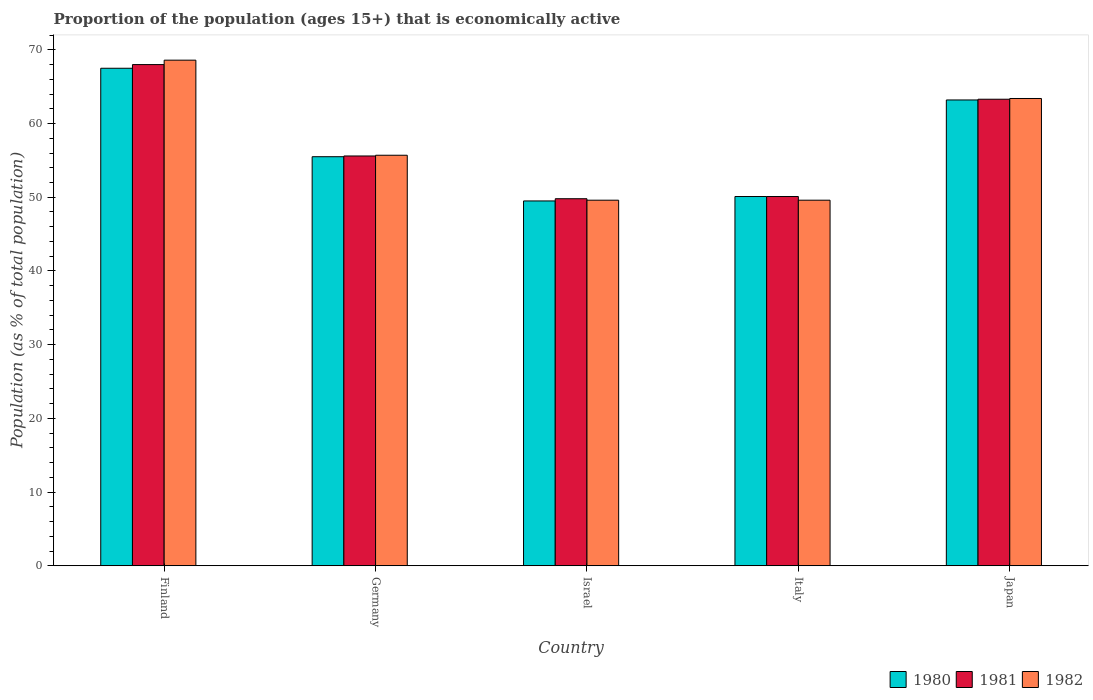How many groups of bars are there?
Give a very brief answer. 5. Are the number of bars on each tick of the X-axis equal?
Your answer should be very brief. Yes. In how many cases, is the number of bars for a given country not equal to the number of legend labels?
Your response must be concise. 0. What is the proportion of the population that is economically active in 1980 in Japan?
Offer a terse response. 63.2. Across all countries, what is the maximum proportion of the population that is economically active in 1980?
Give a very brief answer. 67.5. Across all countries, what is the minimum proportion of the population that is economically active in 1980?
Offer a terse response. 49.5. In which country was the proportion of the population that is economically active in 1980 maximum?
Ensure brevity in your answer.  Finland. What is the total proportion of the population that is economically active in 1980 in the graph?
Ensure brevity in your answer.  285.8. What is the difference between the proportion of the population that is economically active in 1980 in Israel and that in Italy?
Your answer should be very brief. -0.6. What is the difference between the proportion of the population that is economically active in 1982 in Italy and the proportion of the population that is economically active in 1981 in Finland?
Provide a succinct answer. -18.4. What is the average proportion of the population that is economically active in 1981 per country?
Offer a terse response. 57.36. What is the difference between the proportion of the population that is economically active of/in 1981 and proportion of the population that is economically active of/in 1980 in Japan?
Ensure brevity in your answer.  0.1. What is the ratio of the proportion of the population that is economically active in 1982 in Finland to that in Israel?
Offer a very short reply. 1.38. Is the proportion of the population that is economically active in 1981 in Italy less than that in Japan?
Give a very brief answer. Yes. Is the difference between the proportion of the population that is economically active in 1981 in Israel and Japan greater than the difference between the proportion of the population that is economically active in 1980 in Israel and Japan?
Give a very brief answer. Yes. What is the difference between the highest and the second highest proportion of the population that is economically active in 1981?
Your answer should be very brief. 12.4. What is the difference between the highest and the lowest proportion of the population that is economically active in 1982?
Offer a terse response. 19. In how many countries, is the proportion of the population that is economically active in 1980 greater than the average proportion of the population that is economically active in 1980 taken over all countries?
Your answer should be very brief. 2. Is it the case that in every country, the sum of the proportion of the population that is economically active in 1980 and proportion of the population that is economically active in 1982 is greater than the proportion of the population that is economically active in 1981?
Your answer should be very brief. Yes. How many bars are there?
Your answer should be compact. 15. What is the difference between two consecutive major ticks on the Y-axis?
Provide a succinct answer. 10. Are the values on the major ticks of Y-axis written in scientific E-notation?
Keep it short and to the point. No. Does the graph contain grids?
Keep it short and to the point. No. Where does the legend appear in the graph?
Offer a terse response. Bottom right. How many legend labels are there?
Keep it short and to the point. 3. How are the legend labels stacked?
Your answer should be compact. Horizontal. What is the title of the graph?
Give a very brief answer. Proportion of the population (ages 15+) that is economically active. Does "1980" appear as one of the legend labels in the graph?
Keep it short and to the point. Yes. What is the label or title of the X-axis?
Provide a short and direct response. Country. What is the label or title of the Y-axis?
Your response must be concise. Population (as % of total population). What is the Population (as % of total population) of 1980 in Finland?
Offer a terse response. 67.5. What is the Population (as % of total population) of 1982 in Finland?
Your answer should be compact. 68.6. What is the Population (as % of total population) in 1980 in Germany?
Ensure brevity in your answer.  55.5. What is the Population (as % of total population) in 1981 in Germany?
Provide a succinct answer. 55.6. What is the Population (as % of total population) of 1982 in Germany?
Give a very brief answer. 55.7. What is the Population (as % of total population) in 1980 in Israel?
Your response must be concise. 49.5. What is the Population (as % of total population) of 1981 in Israel?
Offer a very short reply. 49.8. What is the Population (as % of total population) of 1982 in Israel?
Give a very brief answer. 49.6. What is the Population (as % of total population) in 1980 in Italy?
Provide a succinct answer. 50.1. What is the Population (as % of total population) in 1981 in Italy?
Your answer should be very brief. 50.1. What is the Population (as % of total population) in 1982 in Italy?
Offer a terse response. 49.6. What is the Population (as % of total population) of 1980 in Japan?
Your answer should be very brief. 63.2. What is the Population (as % of total population) in 1981 in Japan?
Give a very brief answer. 63.3. What is the Population (as % of total population) of 1982 in Japan?
Ensure brevity in your answer.  63.4. Across all countries, what is the maximum Population (as % of total population) in 1980?
Offer a very short reply. 67.5. Across all countries, what is the maximum Population (as % of total population) in 1981?
Provide a short and direct response. 68. Across all countries, what is the maximum Population (as % of total population) in 1982?
Provide a short and direct response. 68.6. Across all countries, what is the minimum Population (as % of total population) in 1980?
Provide a succinct answer. 49.5. Across all countries, what is the minimum Population (as % of total population) in 1981?
Offer a very short reply. 49.8. Across all countries, what is the minimum Population (as % of total population) of 1982?
Ensure brevity in your answer.  49.6. What is the total Population (as % of total population) in 1980 in the graph?
Keep it short and to the point. 285.8. What is the total Population (as % of total population) in 1981 in the graph?
Your answer should be very brief. 286.8. What is the total Population (as % of total population) of 1982 in the graph?
Provide a short and direct response. 286.9. What is the difference between the Population (as % of total population) of 1980 in Finland and that in Germany?
Offer a terse response. 12. What is the difference between the Population (as % of total population) in 1981 in Finland and that in Germany?
Offer a terse response. 12.4. What is the difference between the Population (as % of total population) in 1980 in Finland and that in Israel?
Your answer should be compact. 18. What is the difference between the Population (as % of total population) of 1981 in Finland and that in Israel?
Keep it short and to the point. 18.2. What is the difference between the Population (as % of total population) in 1981 in Finland and that in Italy?
Offer a very short reply. 17.9. What is the difference between the Population (as % of total population) in 1982 in Finland and that in Italy?
Your answer should be compact. 19. What is the difference between the Population (as % of total population) in 1982 in Finland and that in Japan?
Offer a very short reply. 5.2. What is the difference between the Population (as % of total population) of 1980 in Germany and that in Israel?
Keep it short and to the point. 6. What is the difference between the Population (as % of total population) of 1980 in Germany and that in Italy?
Your response must be concise. 5.4. What is the difference between the Population (as % of total population) in 1982 in Germany and that in Italy?
Give a very brief answer. 6.1. What is the difference between the Population (as % of total population) in 1982 in Germany and that in Japan?
Offer a terse response. -7.7. What is the difference between the Population (as % of total population) in 1982 in Israel and that in Italy?
Provide a succinct answer. 0. What is the difference between the Population (as % of total population) of 1980 in Israel and that in Japan?
Ensure brevity in your answer.  -13.7. What is the difference between the Population (as % of total population) of 1980 in Italy and that in Japan?
Offer a very short reply. -13.1. What is the difference between the Population (as % of total population) in 1980 in Finland and the Population (as % of total population) in 1981 in Germany?
Provide a succinct answer. 11.9. What is the difference between the Population (as % of total population) in 1981 in Finland and the Population (as % of total population) in 1982 in Germany?
Offer a terse response. 12.3. What is the difference between the Population (as % of total population) of 1980 in Finland and the Population (as % of total population) of 1982 in Israel?
Keep it short and to the point. 17.9. What is the difference between the Population (as % of total population) of 1980 in Finland and the Population (as % of total population) of 1982 in Italy?
Provide a short and direct response. 17.9. What is the difference between the Population (as % of total population) of 1981 in Finland and the Population (as % of total population) of 1982 in Italy?
Your answer should be compact. 18.4. What is the difference between the Population (as % of total population) in 1981 in Finland and the Population (as % of total population) in 1982 in Japan?
Keep it short and to the point. 4.6. What is the difference between the Population (as % of total population) of 1980 in Germany and the Population (as % of total population) of 1981 in Israel?
Your answer should be compact. 5.7. What is the difference between the Population (as % of total population) in 1980 in Germany and the Population (as % of total population) in 1982 in Israel?
Provide a short and direct response. 5.9. What is the difference between the Population (as % of total population) in 1981 in Germany and the Population (as % of total population) in 1982 in Israel?
Your response must be concise. 6. What is the difference between the Population (as % of total population) of 1980 in Germany and the Population (as % of total population) of 1981 in Italy?
Your answer should be very brief. 5.4. What is the difference between the Population (as % of total population) in 1981 in Germany and the Population (as % of total population) in 1982 in Italy?
Make the answer very short. 6. What is the difference between the Population (as % of total population) in 1981 in Germany and the Population (as % of total population) in 1982 in Japan?
Provide a succinct answer. -7.8. What is the difference between the Population (as % of total population) of 1980 in Israel and the Population (as % of total population) of 1981 in Italy?
Your answer should be very brief. -0.6. What is the difference between the Population (as % of total population) in 1980 in Israel and the Population (as % of total population) in 1982 in Italy?
Make the answer very short. -0.1. What is the difference between the Population (as % of total population) of 1981 in Israel and the Population (as % of total population) of 1982 in Italy?
Provide a succinct answer. 0.2. What is the difference between the Population (as % of total population) of 1980 in Italy and the Population (as % of total population) of 1981 in Japan?
Make the answer very short. -13.2. What is the difference between the Population (as % of total population) in 1980 in Italy and the Population (as % of total population) in 1982 in Japan?
Provide a short and direct response. -13.3. What is the average Population (as % of total population) in 1980 per country?
Provide a succinct answer. 57.16. What is the average Population (as % of total population) in 1981 per country?
Offer a terse response. 57.36. What is the average Population (as % of total population) in 1982 per country?
Offer a very short reply. 57.38. What is the difference between the Population (as % of total population) in 1980 and Population (as % of total population) in 1981 in Finland?
Your response must be concise. -0.5. What is the difference between the Population (as % of total population) of 1981 and Population (as % of total population) of 1982 in Finland?
Your answer should be very brief. -0.6. What is the difference between the Population (as % of total population) of 1981 and Population (as % of total population) of 1982 in Germany?
Ensure brevity in your answer.  -0.1. What is the difference between the Population (as % of total population) of 1980 and Population (as % of total population) of 1981 in Israel?
Offer a terse response. -0.3. What is the difference between the Population (as % of total population) of 1980 and Population (as % of total population) of 1982 in Israel?
Your answer should be compact. -0.1. What is the difference between the Population (as % of total population) of 1981 and Population (as % of total population) of 1982 in Israel?
Ensure brevity in your answer.  0.2. What is the difference between the Population (as % of total population) of 1980 and Population (as % of total population) of 1982 in Italy?
Your response must be concise. 0.5. What is the difference between the Population (as % of total population) of 1981 and Population (as % of total population) of 1982 in Italy?
Keep it short and to the point. 0.5. What is the ratio of the Population (as % of total population) in 1980 in Finland to that in Germany?
Keep it short and to the point. 1.22. What is the ratio of the Population (as % of total population) in 1981 in Finland to that in Germany?
Make the answer very short. 1.22. What is the ratio of the Population (as % of total population) in 1982 in Finland to that in Germany?
Your answer should be very brief. 1.23. What is the ratio of the Population (as % of total population) in 1980 in Finland to that in Israel?
Offer a terse response. 1.36. What is the ratio of the Population (as % of total population) of 1981 in Finland to that in Israel?
Your response must be concise. 1.37. What is the ratio of the Population (as % of total population) in 1982 in Finland to that in Israel?
Make the answer very short. 1.38. What is the ratio of the Population (as % of total population) in 1980 in Finland to that in Italy?
Give a very brief answer. 1.35. What is the ratio of the Population (as % of total population) of 1981 in Finland to that in Italy?
Your response must be concise. 1.36. What is the ratio of the Population (as % of total population) of 1982 in Finland to that in Italy?
Offer a very short reply. 1.38. What is the ratio of the Population (as % of total population) in 1980 in Finland to that in Japan?
Your answer should be very brief. 1.07. What is the ratio of the Population (as % of total population) of 1981 in Finland to that in Japan?
Offer a terse response. 1.07. What is the ratio of the Population (as % of total population) of 1982 in Finland to that in Japan?
Your answer should be compact. 1.08. What is the ratio of the Population (as % of total population) in 1980 in Germany to that in Israel?
Your answer should be compact. 1.12. What is the ratio of the Population (as % of total population) of 1981 in Germany to that in Israel?
Give a very brief answer. 1.12. What is the ratio of the Population (as % of total population) in 1982 in Germany to that in Israel?
Offer a terse response. 1.12. What is the ratio of the Population (as % of total population) of 1980 in Germany to that in Italy?
Give a very brief answer. 1.11. What is the ratio of the Population (as % of total population) in 1981 in Germany to that in Italy?
Offer a very short reply. 1.11. What is the ratio of the Population (as % of total population) of 1982 in Germany to that in Italy?
Keep it short and to the point. 1.12. What is the ratio of the Population (as % of total population) of 1980 in Germany to that in Japan?
Your answer should be compact. 0.88. What is the ratio of the Population (as % of total population) in 1981 in Germany to that in Japan?
Your answer should be very brief. 0.88. What is the ratio of the Population (as % of total population) of 1982 in Germany to that in Japan?
Your answer should be very brief. 0.88. What is the ratio of the Population (as % of total population) in 1981 in Israel to that in Italy?
Give a very brief answer. 0.99. What is the ratio of the Population (as % of total population) in 1982 in Israel to that in Italy?
Make the answer very short. 1. What is the ratio of the Population (as % of total population) of 1980 in Israel to that in Japan?
Make the answer very short. 0.78. What is the ratio of the Population (as % of total population) of 1981 in Israel to that in Japan?
Your answer should be very brief. 0.79. What is the ratio of the Population (as % of total population) in 1982 in Israel to that in Japan?
Keep it short and to the point. 0.78. What is the ratio of the Population (as % of total population) in 1980 in Italy to that in Japan?
Your answer should be compact. 0.79. What is the ratio of the Population (as % of total population) in 1981 in Italy to that in Japan?
Your answer should be compact. 0.79. What is the ratio of the Population (as % of total population) in 1982 in Italy to that in Japan?
Ensure brevity in your answer.  0.78. What is the difference between the highest and the second highest Population (as % of total population) in 1980?
Your response must be concise. 4.3. What is the difference between the highest and the second highest Population (as % of total population) in 1981?
Your answer should be very brief. 4.7. What is the difference between the highest and the second highest Population (as % of total population) of 1982?
Provide a succinct answer. 5.2. What is the difference between the highest and the lowest Population (as % of total population) of 1982?
Make the answer very short. 19. 